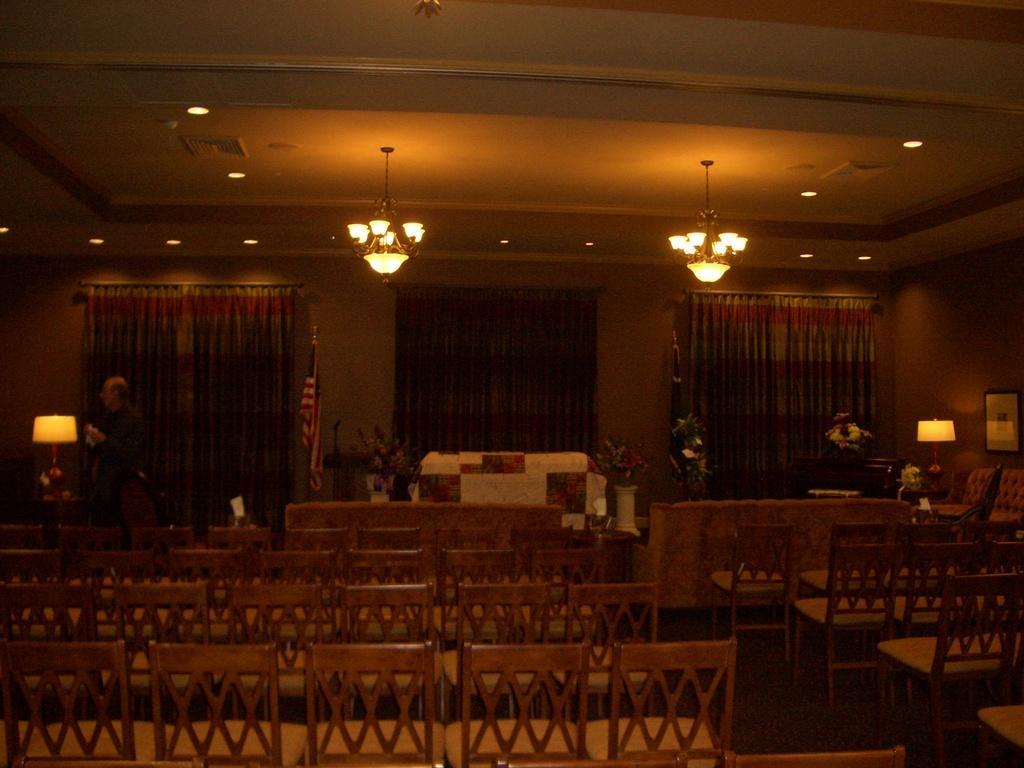How would you summarize this image in a sentence or two? In the picture I can see chairs, tables, flower vases, table lamps, flags, a person standing on the left side of the image, I can see curtains, chandeliers and ceiling lights in the background. 